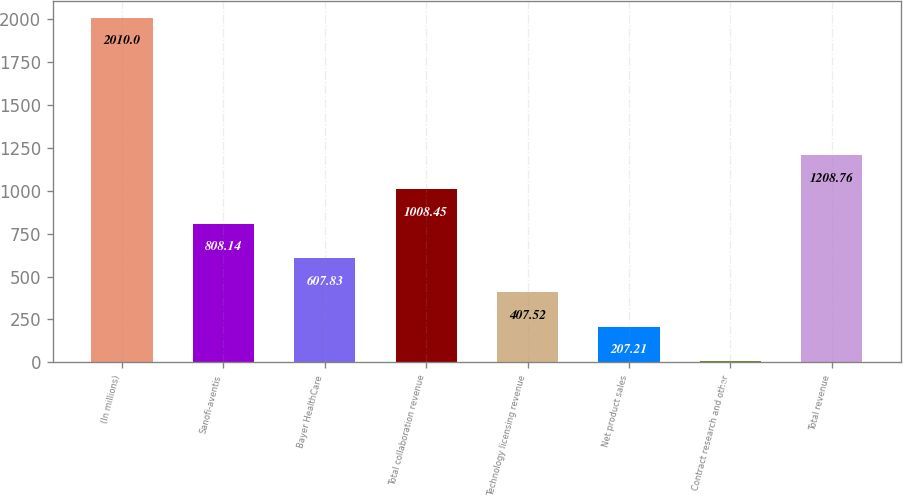Convert chart to OTSL. <chart><loc_0><loc_0><loc_500><loc_500><bar_chart><fcel>(In millions)<fcel>Sanofi-aventis<fcel>Bayer HealthCare<fcel>Total collaboration revenue<fcel>Technology licensing revenue<fcel>Net product sales<fcel>Contract research and other<fcel>Total revenue<nl><fcel>2010<fcel>808.14<fcel>607.83<fcel>1008.45<fcel>407.52<fcel>207.21<fcel>6.9<fcel>1208.76<nl></chart> 